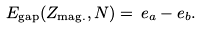Convert formula to latex. <formula><loc_0><loc_0><loc_500><loc_500>E _ { \text {gap} } ( Z _ { \text {mag.} } , N ) = \, e _ { a } - e _ { b } .</formula> 